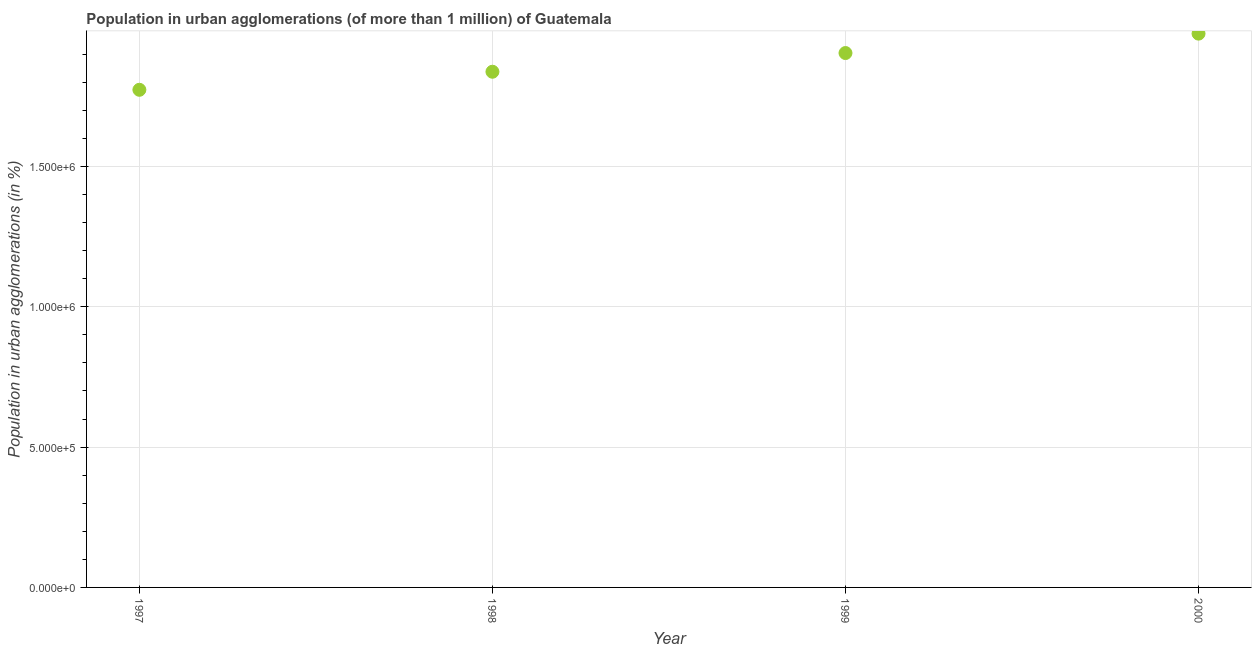What is the population in urban agglomerations in 2000?
Offer a terse response. 1.97e+06. Across all years, what is the maximum population in urban agglomerations?
Your answer should be very brief. 1.97e+06. Across all years, what is the minimum population in urban agglomerations?
Offer a terse response. 1.77e+06. In which year was the population in urban agglomerations maximum?
Your answer should be very brief. 2000. What is the sum of the population in urban agglomerations?
Make the answer very short. 7.49e+06. What is the difference between the population in urban agglomerations in 1997 and 1998?
Ensure brevity in your answer.  -6.43e+04. What is the average population in urban agglomerations per year?
Your response must be concise. 1.87e+06. What is the median population in urban agglomerations?
Your answer should be very brief. 1.87e+06. In how many years, is the population in urban agglomerations greater than 400000 %?
Make the answer very short. 4. What is the ratio of the population in urban agglomerations in 1998 to that in 1999?
Offer a terse response. 0.97. What is the difference between the highest and the second highest population in urban agglomerations?
Offer a terse response. 6.91e+04. Is the sum of the population in urban agglomerations in 1997 and 1998 greater than the maximum population in urban agglomerations across all years?
Your answer should be compact. Yes. What is the difference between the highest and the lowest population in urban agglomerations?
Your response must be concise. 2.00e+05. How many dotlines are there?
Offer a terse response. 1. Are the values on the major ticks of Y-axis written in scientific E-notation?
Offer a terse response. Yes. Does the graph contain any zero values?
Ensure brevity in your answer.  No. Does the graph contain grids?
Your answer should be compact. Yes. What is the title of the graph?
Offer a terse response. Population in urban agglomerations (of more than 1 million) of Guatemala. What is the label or title of the X-axis?
Ensure brevity in your answer.  Year. What is the label or title of the Y-axis?
Ensure brevity in your answer.  Population in urban agglomerations (in %). What is the Population in urban agglomerations (in %) in 1997?
Your answer should be very brief. 1.77e+06. What is the Population in urban agglomerations (in %) in 1998?
Your response must be concise. 1.84e+06. What is the Population in urban agglomerations (in %) in 1999?
Keep it short and to the point. 1.90e+06. What is the Population in urban agglomerations (in %) in 2000?
Offer a very short reply. 1.97e+06. What is the difference between the Population in urban agglomerations (in %) in 1997 and 1998?
Provide a succinct answer. -6.43e+04. What is the difference between the Population in urban agglomerations (in %) in 1997 and 1999?
Provide a short and direct response. -1.31e+05. What is the difference between the Population in urban agglomerations (in %) in 1997 and 2000?
Offer a very short reply. -2.00e+05. What is the difference between the Population in urban agglomerations (in %) in 1998 and 1999?
Offer a terse response. -6.66e+04. What is the difference between the Population in urban agglomerations (in %) in 1998 and 2000?
Provide a short and direct response. -1.36e+05. What is the difference between the Population in urban agglomerations (in %) in 1999 and 2000?
Make the answer very short. -6.91e+04. What is the ratio of the Population in urban agglomerations (in %) in 1997 to that in 1998?
Make the answer very short. 0.96. What is the ratio of the Population in urban agglomerations (in %) in 1997 to that in 1999?
Make the answer very short. 0.93. What is the ratio of the Population in urban agglomerations (in %) in 1997 to that in 2000?
Your answer should be very brief. 0.9. What is the ratio of the Population in urban agglomerations (in %) in 1998 to that in 2000?
Offer a very short reply. 0.93. 